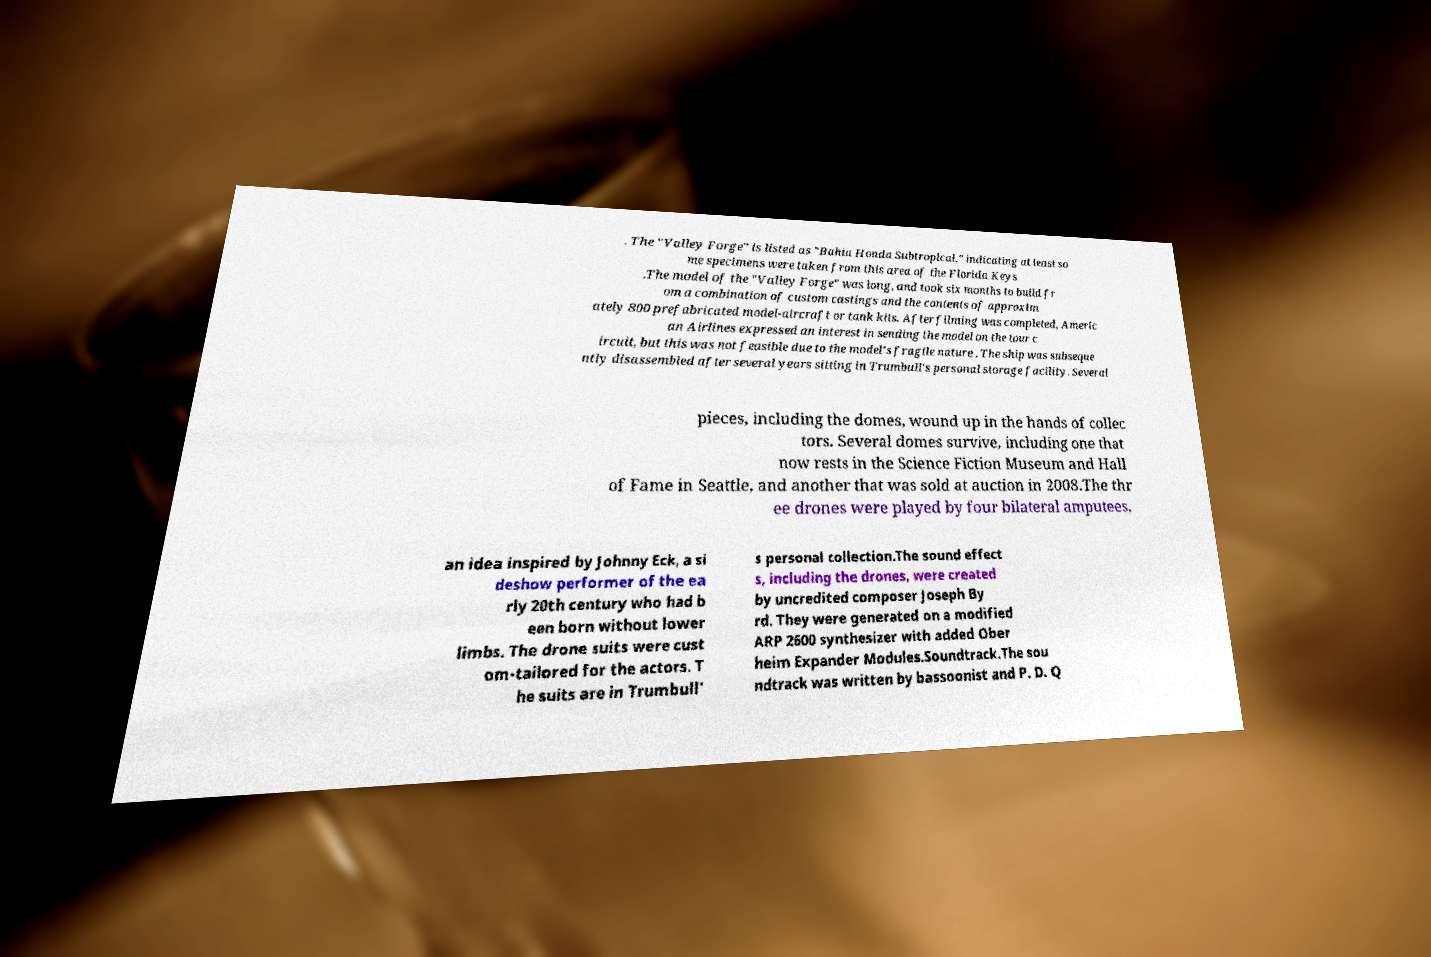What messages or text are displayed in this image? I need them in a readable, typed format. . The "Valley Forge" is listed as "Bahia Honda Subtropical," indicating at least so me specimens were taken from this area of the Florida Keys .The model of the "Valley Forge" was long, and took six months to build fr om a combination of custom castings and the contents of approxim ately 800 prefabricated model-aircraft or tank kits. After filming was completed, Americ an Airlines expressed an interest in sending the model on the tour c ircuit, but this was not feasible due to the model's fragile nature . The ship was subseque ntly disassembled after several years sitting in Trumbull's personal storage facility. Several pieces, including the domes, wound up in the hands of collec tors. Several domes survive, including one that now rests in the Science Fiction Museum and Hall of Fame in Seattle, and another that was sold at auction in 2008.The thr ee drones were played by four bilateral amputees, an idea inspired by Johnny Eck, a si deshow performer of the ea rly 20th century who had b een born without lower limbs. The drone suits were cust om-tailored for the actors. T he suits are in Trumbull' s personal collection.The sound effect s, including the drones, were created by uncredited composer Joseph By rd. They were generated on a modified ARP 2600 synthesizer with added Ober heim Expander Modules.Soundtrack.The sou ndtrack was written by bassoonist and P. D. Q 